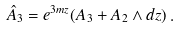<formula> <loc_0><loc_0><loc_500><loc_500>\hat { A } _ { 3 } = e ^ { 3 m z } ( A _ { 3 } + A _ { 2 } \wedge d z ) \, .</formula> 